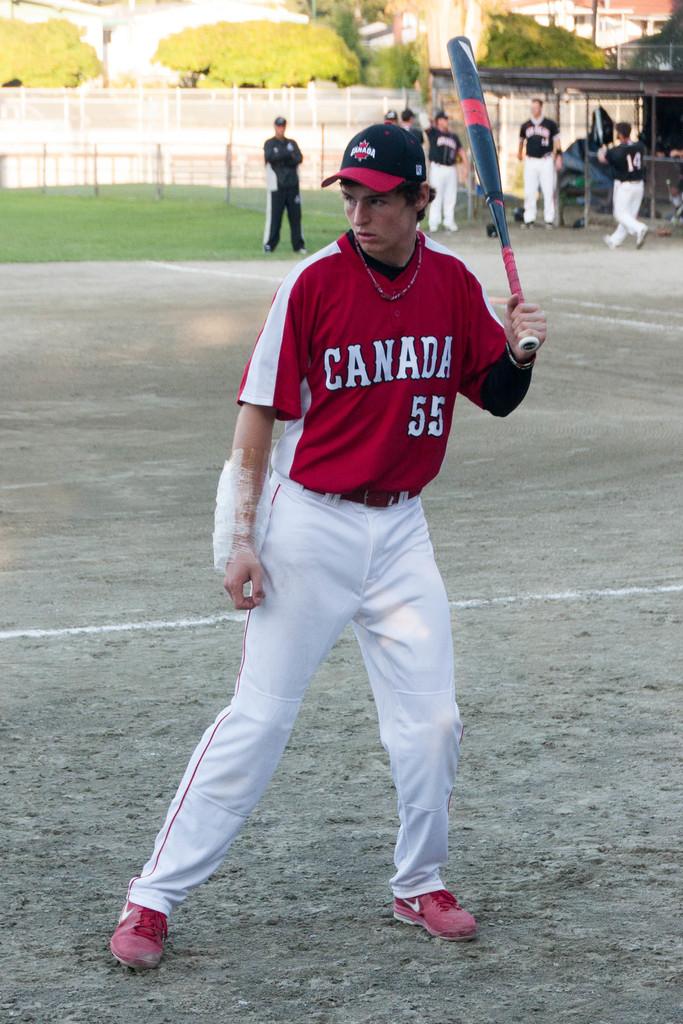Is he on the canadian team?
Provide a short and direct response. Yes. What number is he?
Give a very brief answer. 55. 